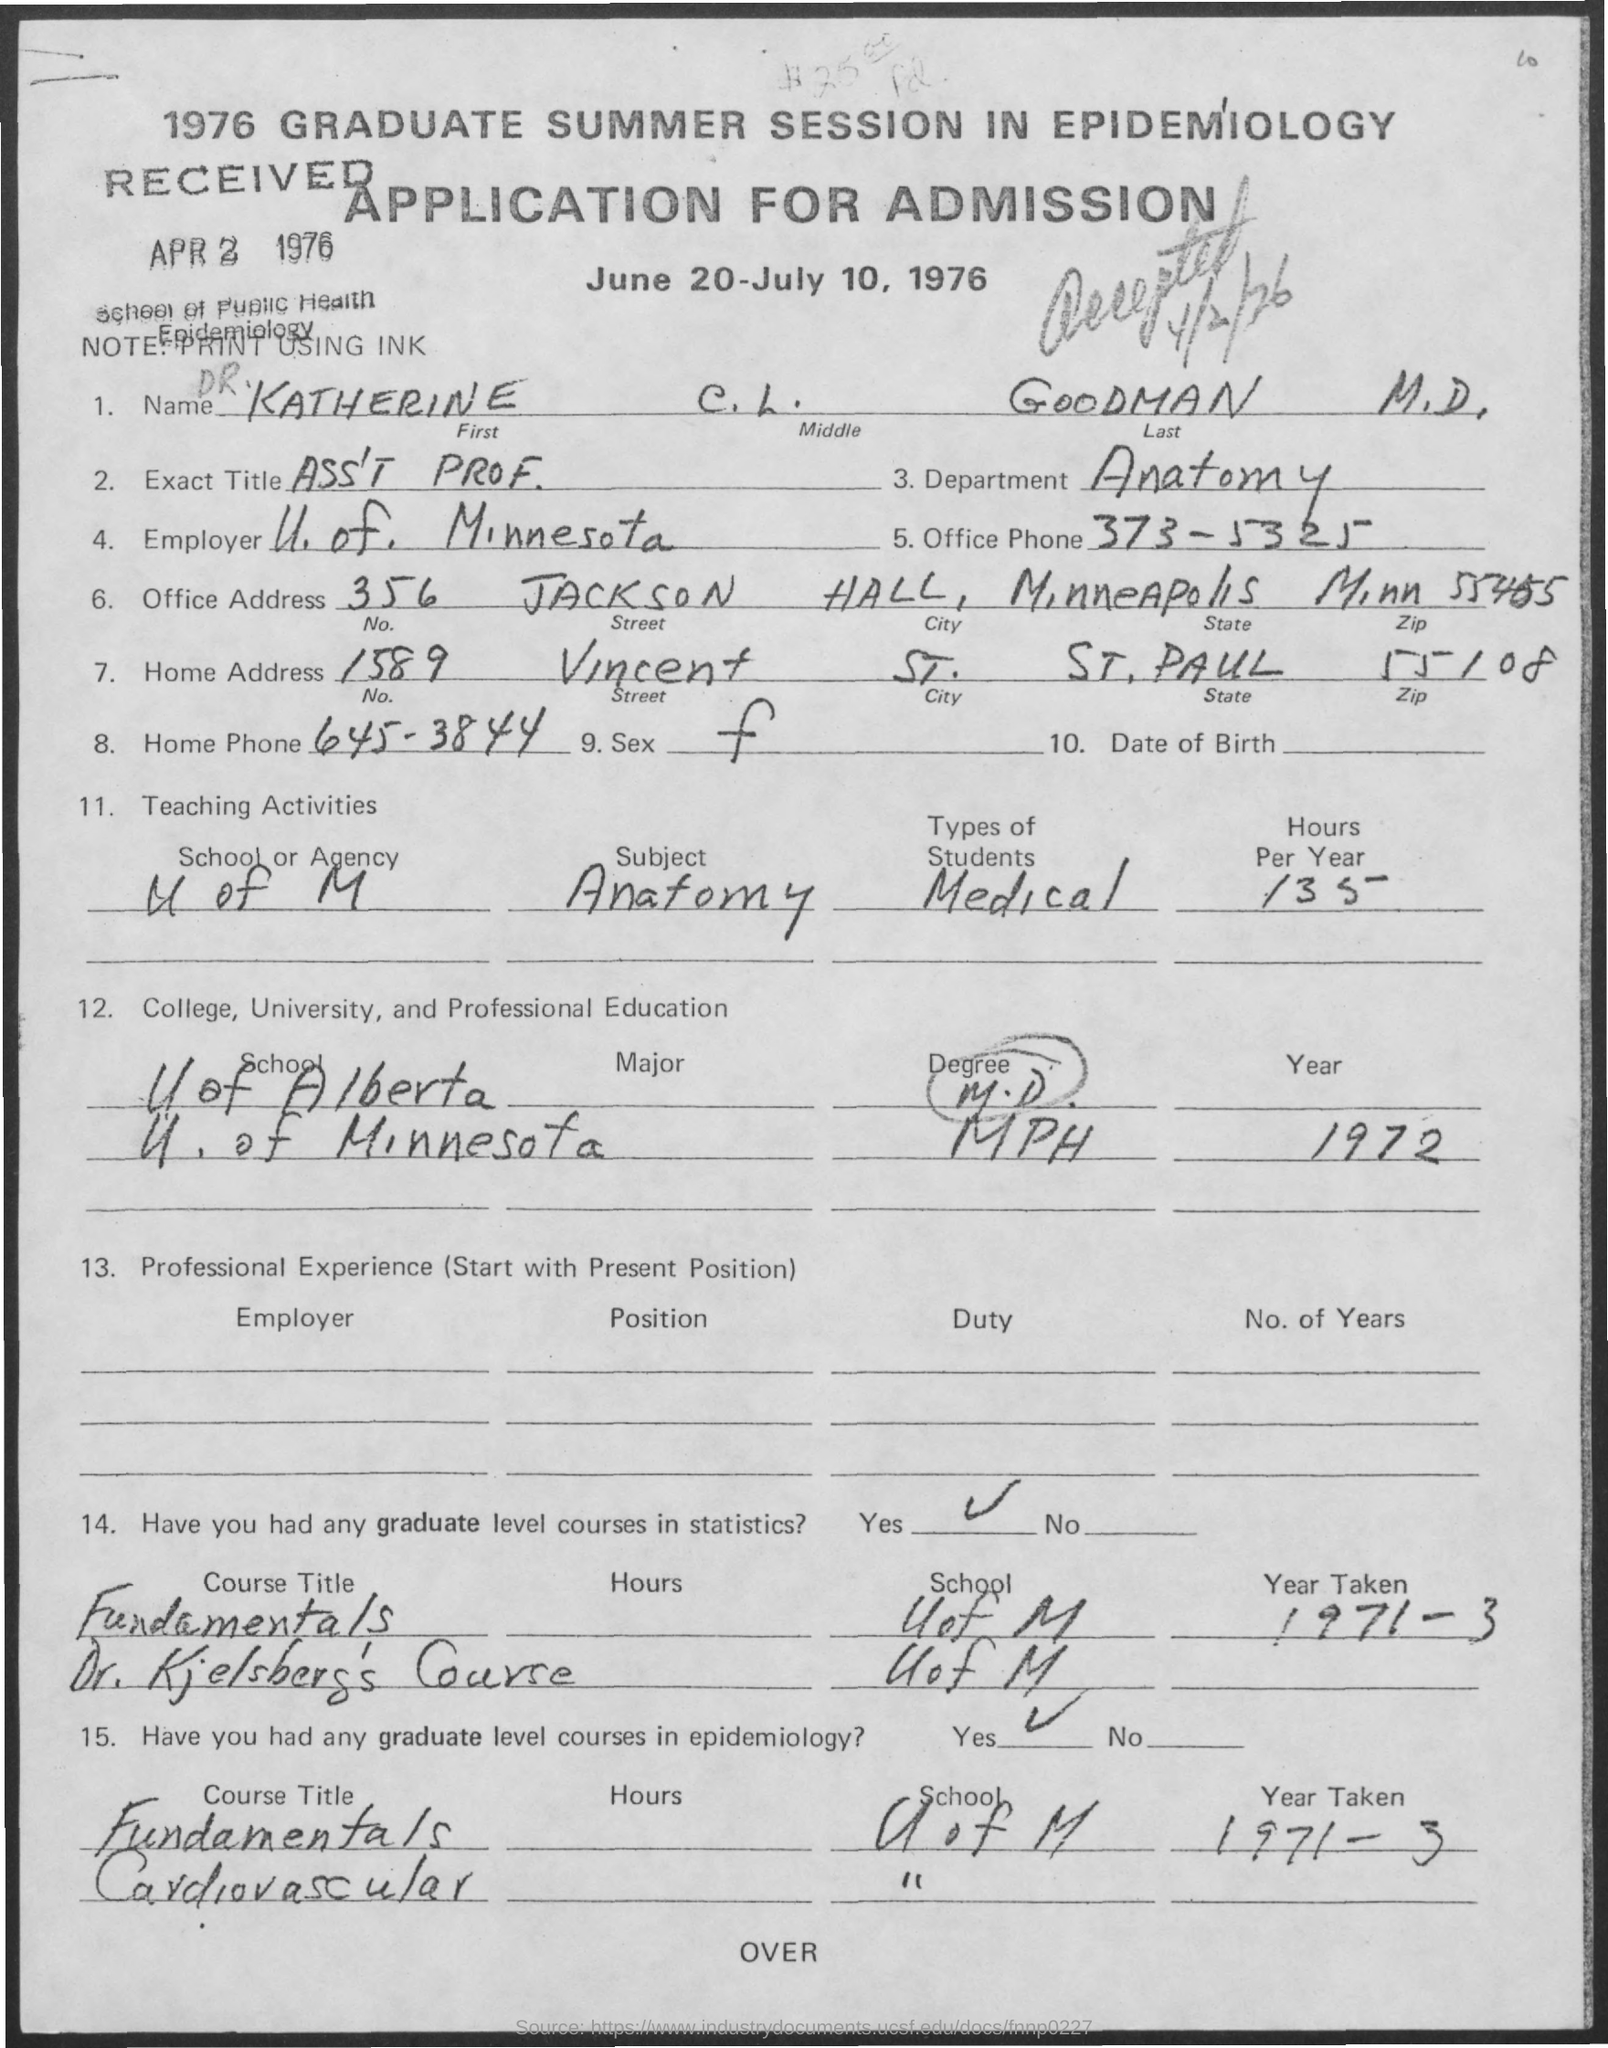Which years summer session in Epidemiology is this?
Provide a succinct answer. 1976. Which session this application for?
Your answer should be very brief. 1976 Graduate summer session in Epidemiology. What is the name of the applicant?
Your answer should be very brief. KATHERINE. Who is the employer?
Make the answer very short. U.OF. MINNESOTA. Which Department Does application belong to?
Make the answer very short. Anatomy. How many hours per year was spent on teaching anatomy at U of M?
Keep it short and to the point. 135. In which university dud the applicant take   statistics course?
Your answer should be very brief. UOF M. In which period did the applicant take a graduate level course on fundamentals of  epidemiology?
Provide a short and direct response. 1971-3. In which period did the applicant take a graduate level course in statistics?
Keep it short and to the point. 1971-3. 